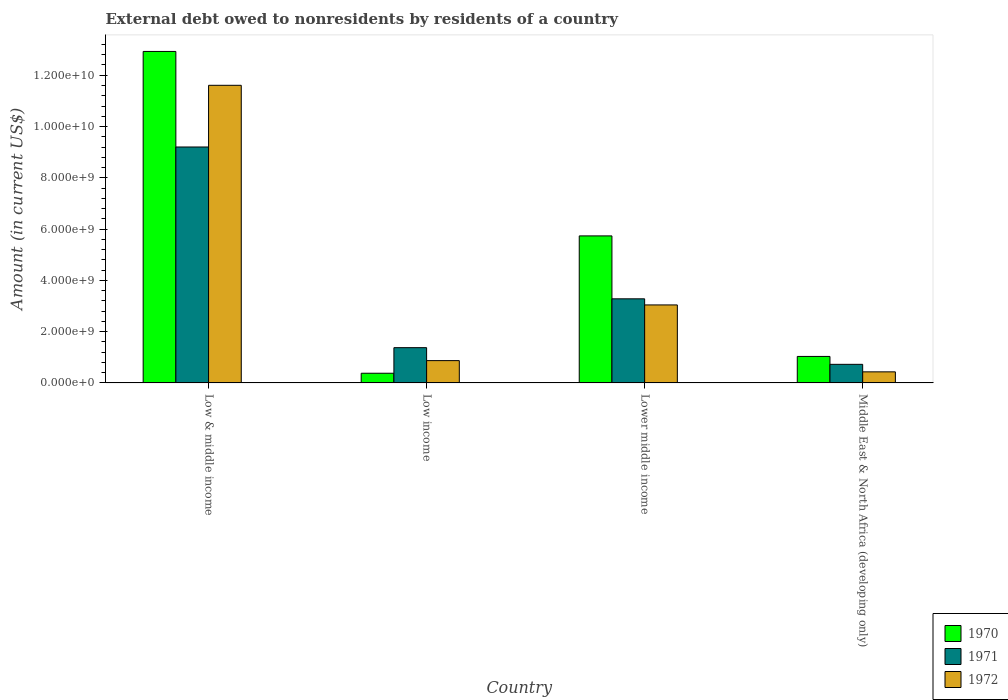How many groups of bars are there?
Provide a succinct answer. 4. Are the number of bars on each tick of the X-axis equal?
Your answer should be compact. Yes. How many bars are there on the 1st tick from the left?
Provide a short and direct response. 3. How many bars are there on the 4th tick from the right?
Your response must be concise. 3. What is the label of the 3rd group of bars from the left?
Provide a succinct answer. Lower middle income. In how many cases, is the number of bars for a given country not equal to the number of legend labels?
Keep it short and to the point. 0. What is the external debt owed by residents in 1970 in Lower middle income?
Provide a short and direct response. 5.73e+09. Across all countries, what is the maximum external debt owed by residents in 1970?
Make the answer very short. 1.29e+1. Across all countries, what is the minimum external debt owed by residents in 1970?
Your answer should be compact. 3.78e+08. In which country was the external debt owed by residents in 1971 minimum?
Your answer should be very brief. Middle East & North Africa (developing only). What is the total external debt owed by residents in 1971 in the graph?
Ensure brevity in your answer.  1.46e+1. What is the difference between the external debt owed by residents in 1970 in Low income and that in Middle East & North Africa (developing only)?
Offer a terse response. -6.56e+08. What is the difference between the external debt owed by residents in 1972 in Low income and the external debt owed by residents in 1971 in Middle East & North Africa (developing only)?
Ensure brevity in your answer.  1.45e+08. What is the average external debt owed by residents in 1971 per country?
Your answer should be very brief. 3.65e+09. What is the difference between the external debt owed by residents of/in 1970 and external debt owed by residents of/in 1971 in Middle East & North Africa (developing only)?
Provide a short and direct response. 3.09e+08. What is the ratio of the external debt owed by residents in 1972 in Low income to that in Lower middle income?
Your response must be concise. 0.29. Is the difference between the external debt owed by residents in 1970 in Low & middle income and Middle East & North Africa (developing only) greater than the difference between the external debt owed by residents in 1971 in Low & middle income and Middle East & North Africa (developing only)?
Offer a terse response. Yes. What is the difference between the highest and the second highest external debt owed by residents in 1970?
Keep it short and to the point. -4.70e+09. What is the difference between the highest and the lowest external debt owed by residents in 1972?
Provide a short and direct response. 1.12e+1. What does the 1st bar from the left in Low & middle income represents?
Give a very brief answer. 1970. Is it the case that in every country, the sum of the external debt owed by residents in 1970 and external debt owed by residents in 1971 is greater than the external debt owed by residents in 1972?
Provide a succinct answer. Yes. How many bars are there?
Offer a very short reply. 12. Are all the bars in the graph horizontal?
Make the answer very short. No. What is the difference between two consecutive major ticks on the Y-axis?
Provide a short and direct response. 2.00e+09. Does the graph contain any zero values?
Your response must be concise. No. How many legend labels are there?
Your answer should be compact. 3. How are the legend labels stacked?
Your response must be concise. Vertical. What is the title of the graph?
Provide a short and direct response. External debt owed to nonresidents by residents of a country. Does "2000" appear as one of the legend labels in the graph?
Ensure brevity in your answer.  No. What is the label or title of the X-axis?
Make the answer very short. Country. What is the label or title of the Y-axis?
Offer a very short reply. Amount (in current US$). What is the Amount (in current US$) of 1970 in Low & middle income?
Give a very brief answer. 1.29e+1. What is the Amount (in current US$) in 1971 in Low & middle income?
Your response must be concise. 9.20e+09. What is the Amount (in current US$) in 1972 in Low & middle income?
Make the answer very short. 1.16e+1. What is the Amount (in current US$) in 1970 in Low income?
Your answer should be very brief. 3.78e+08. What is the Amount (in current US$) of 1971 in Low income?
Ensure brevity in your answer.  1.38e+09. What is the Amount (in current US$) in 1972 in Low income?
Ensure brevity in your answer.  8.71e+08. What is the Amount (in current US$) of 1970 in Lower middle income?
Offer a terse response. 5.73e+09. What is the Amount (in current US$) in 1971 in Lower middle income?
Ensure brevity in your answer.  3.28e+09. What is the Amount (in current US$) of 1972 in Lower middle income?
Keep it short and to the point. 3.04e+09. What is the Amount (in current US$) in 1970 in Middle East & North Africa (developing only)?
Offer a very short reply. 1.03e+09. What is the Amount (in current US$) of 1971 in Middle East & North Africa (developing only)?
Offer a terse response. 7.25e+08. What is the Amount (in current US$) of 1972 in Middle East & North Africa (developing only)?
Provide a short and direct response. 4.33e+08. Across all countries, what is the maximum Amount (in current US$) of 1970?
Provide a short and direct response. 1.29e+1. Across all countries, what is the maximum Amount (in current US$) in 1971?
Offer a terse response. 9.20e+09. Across all countries, what is the maximum Amount (in current US$) of 1972?
Keep it short and to the point. 1.16e+1. Across all countries, what is the minimum Amount (in current US$) in 1970?
Keep it short and to the point. 3.78e+08. Across all countries, what is the minimum Amount (in current US$) in 1971?
Offer a very short reply. 7.25e+08. Across all countries, what is the minimum Amount (in current US$) in 1972?
Your answer should be compact. 4.33e+08. What is the total Amount (in current US$) of 1970 in the graph?
Make the answer very short. 2.01e+1. What is the total Amount (in current US$) of 1971 in the graph?
Make the answer very short. 1.46e+1. What is the total Amount (in current US$) in 1972 in the graph?
Provide a succinct answer. 1.60e+1. What is the difference between the Amount (in current US$) of 1970 in Low & middle income and that in Low income?
Your response must be concise. 1.25e+1. What is the difference between the Amount (in current US$) in 1971 in Low & middle income and that in Low income?
Give a very brief answer. 7.83e+09. What is the difference between the Amount (in current US$) of 1972 in Low & middle income and that in Low income?
Give a very brief answer. 1.07e+1. What is the difference between the Amount (in current US$) of 1970 in Low & middle income and that in Lower middle income?
Your answer should be very brief. 7.19e+09. What is the difference between the Amount (in current US$) of 1971 in Low & middle income and that in Lower middle income?
Keep it short and to the point. 5.92e+09. What is the difference between the Amount (in current US$) of 1972 in Low & middle income and that in Lower middle income?
Offer a very short reply. 8.57e+09. What is the difference between the Amount (in current US$) of 1970 in Low & middle income and that in Middle East & North Africa (developing only)?
Ensure brevity in your answer.  1.19e+1. What is the difference between the Amount (in current US$) of 1971 in Low & middle income and that in Middle East & North Africa (developing only)?
Keep it short and to the point. 8.48e+09. What is the difference between the Amount (in current US$) of 1972 in Low & middle income and that in Middle East & North Africa (developing only)?
Ensure brevity in your answer.  1.12e+1. What is the difference between the Amount (in current US$) in 1970 in Low income and that in Lower middle income?
Give a very brief answer. -5.36e+09. What is the difference between the Amount (in current US$) in 1971 in Low income and that in Lower middle income?
Your answer should be very brief. -1.90e+09. What is the difference between the Amount (in current US$) in 1972 in Low income and that in Lower middle income?
Provide a succinct answer. -2.17e+09. What is the difference between the Amount (in current US$) of 1970 in Low income and that in Middle East & North Africa (developing only)?
Offer a very short reply. -6.56e+08. What is the difference between the Amount (in current US$) in 1971 in Low income and that in Middle East & North Africa (developing only)?
Your answer should be very brief. 6.50e+08. What is the difference between the Amount (in current US$) of 1972 in Low income and that in Middle East & North Africa (developing only)?
Your answer should be very brief. 4.38e+08. What is the difference between the Amount (in current US$) of 1970 in Lower middle income and that in Middle East & North Africa (developing only)?
Give a very brief answer. 4.70e+09. What is the difference between the Amount (in current US$) of 1971 in Lower middle income and that in Middle East & North Africa (developing only)?
Ensure brevity in your answer.  2.56e+09. What is the difference between the Amount (in current US$) of 1972 in Lower middle income and that in Middle East & North Africa (developing only)?
Provide a succinct answer. 2.61e+09. What is the difference between the Amount (in current US$) in 1970 in Low & middle income and the Amount (in current US$) in 1971 in Low income?
Offer a terse response. 1.16e+1. What is the difference between the Amount (in current US$) of 1970 in Low & middle income and the Amount (in current US$) of 1972 in Low income?
Your response must be concise. 1.21e+1. What is the difference between the Amount (in current US$) of 1971 in Low & middle income and the Amount (in current US$) of 1972 in Low income?
Ensure brevity in your answer.  8.33e+09. What is the difference between the Amount (in current US$) in 1970 in Low & middle income and the Amount (in current US$) in 1971 in Lower middle income?
Your answer should be very brief. 9.65e+09. What is the difference between the Amount (in current US$) of 1970 in Low & middle income and the Amount (in current US$) of 1972 in Lower middle income?
Your answer should be very brief. 9.89e+09. What is the difference between the Amount (in current US$) of 1971 in Low & middle income and the Amount (in current US$) of 1972 in Lower middle income?
Your answer should be compact. 6.16e+09. What is the difference between the Amount (in current US$) of 1970 in Low & middle income and the Amount (in current US$) of 1971 in Middle East & North Africa (developing only)?
Ensure brevity in your answer.  1.22e+1. What is the difference between the Amount (in current US$) in 1970 in Low & middle income and the Amount (in current US$) in 1972 in Middle East & North Africa (developing only)?
Provide a short and direct response. 1.25e+1. What is the difference between the Amount (in current US$) of 1971 in Low & middle income and the Amount (in current US$) of 1972 in Middle East & North Africa (developing only)?
Ensure brevity in your answer.  8.77e+09. What is the difference between the Amount (in current US$) of 1970 in Low income and the Amount (in current US$) of 1971 in Lower middle income?
Ensure brevity in your answer.  -2.90e+09. What is the difference between the Amount (in current US$) in 1970 in Low income and the Amount (in current US$) in 1972 in Lower middle income?
Your answer should be very brief. -2.66e+09. What is the difference between the Amount (in current US$) in 1971 in Low income and the Amount (in current US$) in 1972 in Lower middle income?
Offer a very short reply. -1.67e+09. What is the difference between the Amount (in current US$) of 1970 in Low income and the Amount (in current US$) of 1971 in Middle East & North Africa (developing only)?
Provide a succinct answer. -3.47e+08. What is the difference between the Amount (in current US$) of 1970 in Low income and the Amount (in current US$) of 1972 in Middle East & North Africa (developing only)?
Keep it short and to the point. -5.41e+07. What is the difference between the Amount (in current US$) in 1971 in Low income and the Amount (in current US$) in 1972 in Middle East & North Africa (developing only)?
Your answer should be very brief. 9.43e+08. What is the difference between the Amount (in current US$) in 1970 in Lower middle income and the Amount (in current US$) in 1971 in Middle East & North Africa (developing only)?
Make the answer very short. 5.01e+09. What is the difference between the Amount (in current US$) of 1970 in Lower middle income and the Amount (in current US$) of 1972 in Middle East & North Africa (developing only)?
Keep it short and to the point. 5.30e+09. What is the difference between the Amount (in current US$) of 1971 in Lower middle income and the Amount (in current US$) of 1972 in Middle East & North Africa (developing only)?
Your response must be concise. 2.85e+09. What is the average Amount (in current US$) in 1970 per country?
Give a very brief answer. 5.02e+09. What is the average Amount (in current US$) in 1971 per country?
Make the answer very short. 3.65e+09. What is the average Amount (in current US$) in 1972 per country?
Keep it short and to the point. 3.99e+09. What is the difference between the Amount (in current US$) of 1970 and Amount (in current US$) of 1971 in Low & middle income?
Your answer should be very brief. 3.73e+09. What is the difference between the Amount (in current US$) in 1970 and Amount (in current US$) in 1972 in Low & middle income?
Your response must be concise. 1.32e+09. What is the difference between the Amount (in current US$) in 1971 and Amount (in current US$) in 1972 in Low & middle income?
Your response must be concise. -2.41e+09. What is the difference between the Amount (in current US$) in 1970 and Amount (in current US$) in 1971 in Low income?
Offer a very short reply. -9.97e+08. What is the difference between the Amount (in current US$) in 1970 and Amount (in current US$) in 1972 in Low income?
Your response must be concise. -4.92e+08. What is the difference between the Amount (in current US$) of 1971 and Amount (in current US$) of 1972 in Low income?
Offer a terse response. 5.05e+08. What is the difference between the Amount (in current US$) in 1970 and Amount (in current US$) in 1971 in Lower middle income?
Provide a succinct answer. 2.45e+09. What is the difference between the Amount (in current US$) in 1970 and Amount (in current US$) in 1972 in Lower middle income?
Provide a short and direct response. 2.69e+09. What is the difference between the Amount (in current US$) in 1971 and Amount (in current US$) in 1972 in Lower middle income?
Make the answer very short. 2.39e+08. What is the difference between the Amount (in current US$) in 1970 and Amount (in current US$) in 1971 in Middle East & North Africa (developing only)?
Give a very brief answer. 3.09e+08. What is the difference between the Amount (in current US$) of 1970 and Amount (in current US$) of 1972 in Middle East & North Africa (developing only)?
Your answer should be compact. 6.02e+08. What is the difference between the Amount (in current US$) in 1971 and Amount (in current US$) in 1972 in Middle East & North Africa (developing only)?
Offer a terse response. 2.93e+08. What is the ratio of the Amount (in current US$) in 1970 in Low & middle income to that in Low income?
Your response must be concise. 34.16. What is the ratio of the Amount (in current US$) in 1971 in Low & middle income to that in Low income?
Provide a short and direct response. 6.69. What is the ratio of the Amount (in current US$) in 1972 in Low & middle income to that in Low income?
Your answer should be compact. 13.33. What is the ratio of the Amount (in current US$) of 1970 in Low & middle income to that in Lower middle income?
Your answer should be very brief. 2.25. What is the ratio of the Amount (in current US$) of 1971 in Low & middle income to that in Lower middle income?
Give a very brief answer. 2.8. What is the ratio of the Amount (in current US$) of 1972 in Low & middle income to that in Lower middle income?
Provide a short and direct response. 3.82. What is the ratio of the Amount (in current US$) in 1970 in Low & middle income to that in Middle East & North Africa (developing only)?
Offer a very short reply. 12.5. What is the ratio of the Amount (in current US$) of 1971 in Low & middle income to that in Middle East & North Africa (developing only)?
Give a very brief answer. 12.69. What is the ratio of the Amount (in current US$) in 1972 in Low & middle income to that in Middle East & North Africa (developing only)?
Ensure brevity in your answer.  26.84. What is the ratio of the Amount (in current US$) of 1970 in Low income to that in Lower middle income?
Make the answer very short. 0.07. What is the ratio of the Amount (in current US$) in 1971 in Low income to that in Lower middle income?
Offer a very short reply. 0.42. What is the ratio of the Amount (in current US$) in 1972 in Low income to that in Lower middle income?
Offer a very short reply. 0.29. What is the ratio of the Amount (in current US$) in 1970 in Low income to that in Middle East & North Africa (developing only)?
Your answer should be very brief. 0.37. What is the ratio of the Amount (in current US$) in 1971 in Low income to that in Middle East & North Africa (developing only)?
Your response must be concise. 1.9. What is the ratio of the Amount (in current US$) of 1972 in Low income to that in Middle East & North Africa (developing only)?
Make the answer very short. 2.01. What is the ratio of the Amount (in current US$) in 1970 in Lower middle income to that in Middle East & North Africa (developing only)?
Keep it short and to the point. 5.55. What is the ratio of the Amount (in current US$) of 1971 in Lower middle income to that in Middle East & North Africa (developing only)?
Provide a succinct answer. 4.52. What is the ratio of the Amount (in current US$) of 1972 in Lower middle income to that in Middle East & North Africa (developing only)?
Provide a succinct answer. 7.03. What is the difference between the highest and the second highest Amount (in current US$) of 1970?
Make the answer very short. 7.19e+09. What is the difference between the highest and the second highest Amount (in current US$) of 1971?
Provide a succinct answer. 5.92e+09. What is the difference between the highest and the second highest Amount (in current US$) of 1972?
Make the answer very short. 8.57e+09. What is the difference between the highest and the lowest Amount (in current US$) of 1970?
Ensure brevity in your answer.  1.25e+1. What is the difference between the highest and the lowest Amount (in current US$) in 1971?
Offer a terse response. 8.48e+09. What is the difference between the highest and the lowest Amount (in current US$) of 1972?
Offer a very short reply. 1.12e+1. 